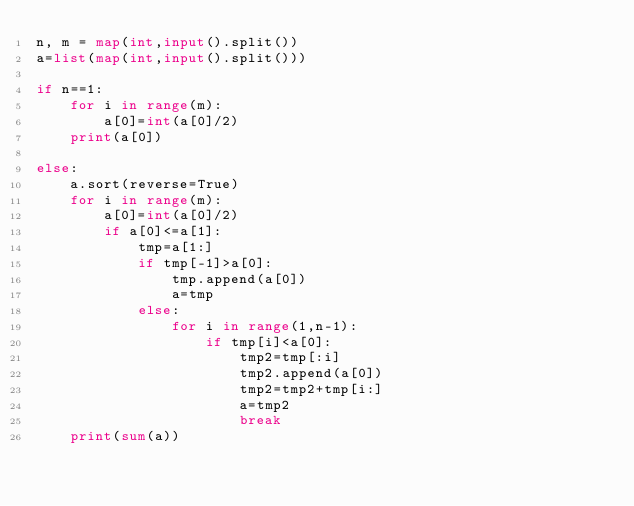Convert code to text. <code><loc_0><loc_0><loc_500><loc_500><_Python_>n, m = map(int,input().split())
a=list(map(int,input().split()))

if n==1:
    for i in range(m):
        a[0]=int(a[0]/2)
    print(a[0])
    
else:
    a.sort(reverse=True)
    for i in range(m):
        a[0]=int(a[0]/2)
        if a[0]<=a[1]:
            tmp=a[1:]
            if tmp[-1]>a[0]:
                tmp.append(a[0])
                a=tmp
            else:
                for i in range(1,n-1):
                    if tmp[i]<a[0]:
                        tmp2=tmp[:i]
                        tmp2.append(a[0])
                        tmp2=tmp2+tmp[i:]
                        a=tmp2
                        break  
    print(sum(a))</code> 